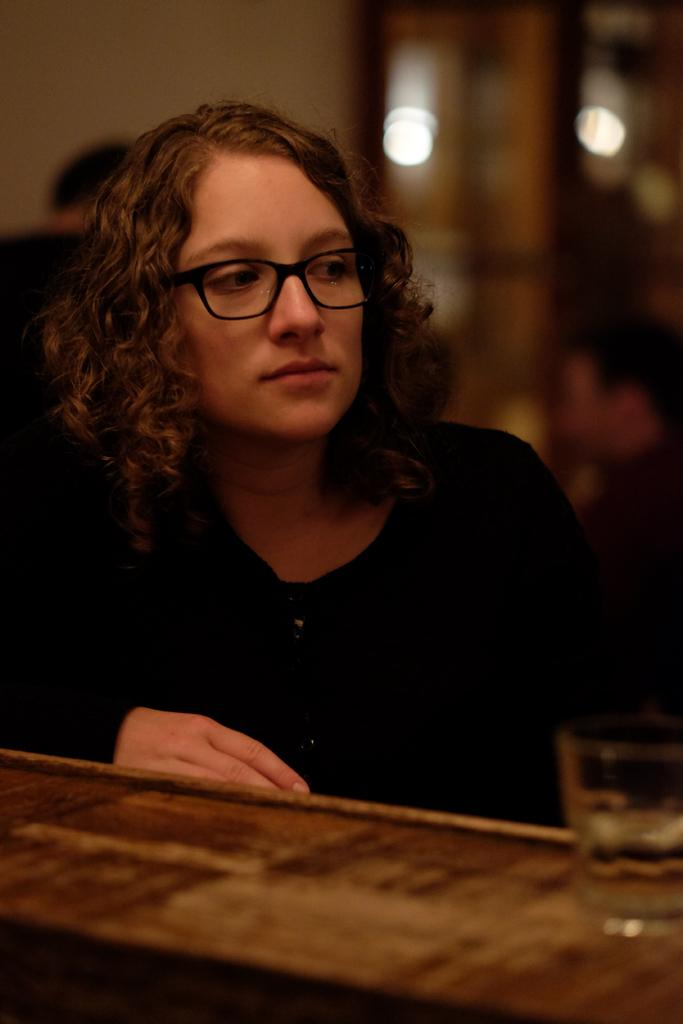Who is the main subject in the image? There is a woman in the image. What is the woman doing in the image? The woman is looking to the right. What accessory is the woman wearing in the image? The woman is wearing spectacles. What object is on the table in front of the woman? There is a glass on the table in front of the woman. Can you describe the background of the image? The background of the image is blurry. What type of suit is the woman wearing in the image? There is no suit visible in the image; the woman is wearing spectacles, but no clothing is mentioned in the facts provided. 